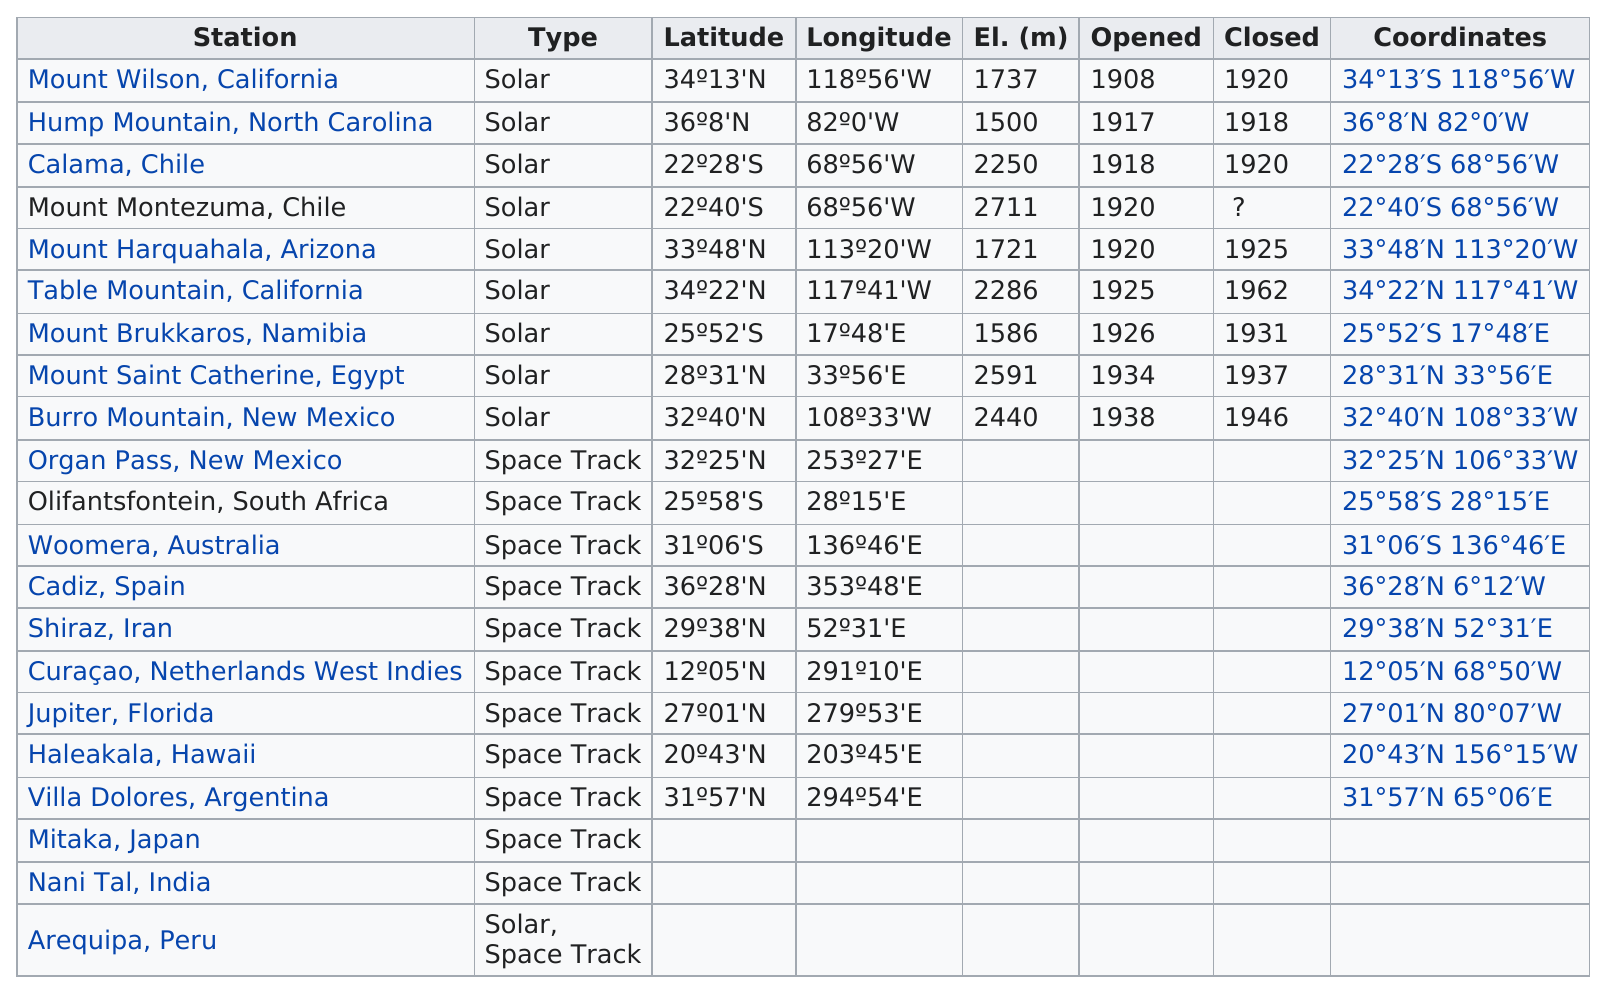Specify some key components in this picture. The first opened station was located in Mount Wilson, California. The highest elevation recorded at this station is 2591 meters, at Mount Saint Catherine in Egypt. The total operating years of Table Mountain in California are 37. The location of Calama, Chile is closer to the equator than the location of Cadiz, Spain. Six stations were opened before 1926. 